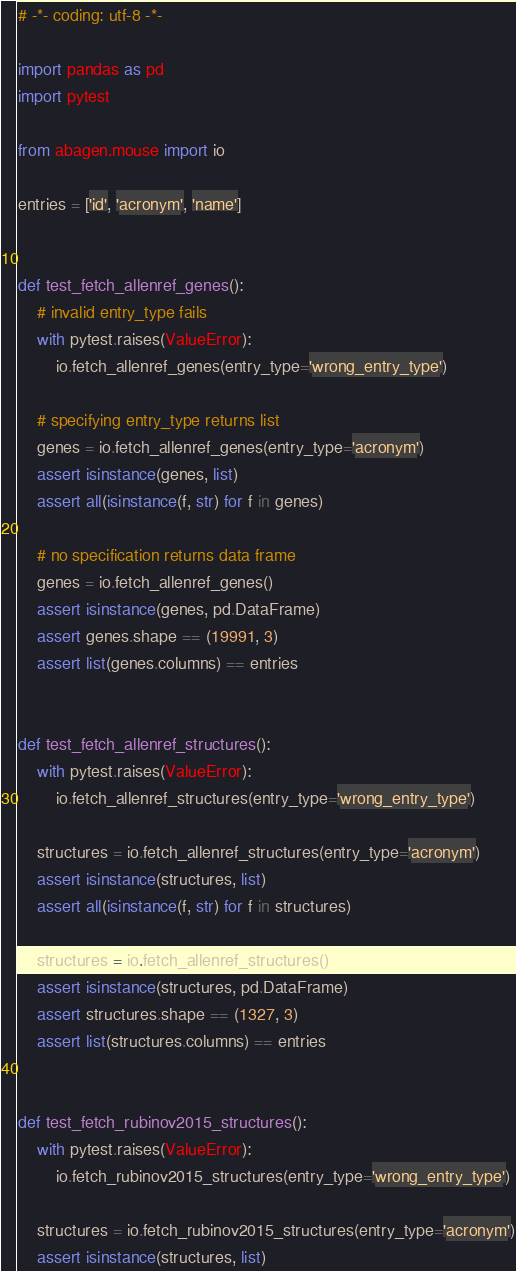<code> <loc_0><loc_0><loc_500><loc_500><_Python_># -*- coding: utf-8 -*-

import pandas as pd
import pytest

from abagen.mouse import io

entries = ['id', 'acronym', 'name']


def test_fetch_allenref_genes():
    # invalid entry_type fails
    with pytest.raises(ValueError):
        io.fetch_allenref_genes(entry_type='wrong_entry_type')

    # specifying entry_type returns list
    genes = io.fetch_allenref_genes(entry_type='acronym')
    assert isinstance(genes, list)
    assert all(isinstance(f, str) for f in genes)

    # no specification returns data frame
    genes = io.fetch_allenref_genes()
    assert isinstance(genes, pd.DataFrame)
    assert genes.shape == (19991, 3)
    assert list(genes.columns) == entries


def test_fetch_allenref_structures():
    with pytest.raises(ValueError):
        io.fetch_allenref_structures(entry_type='wrong_entry_type')

    structures = io.fetch_allenref_structures(entry_type='acronym')
    assert isinstance(structures, list)
    assert all(isinstance(f, str) for f in structures)

    structures = io.fetch_allenref_structures()
    assert isinstance(structures, pd.DataFrame)
    assert structures.shape == (1327, 3)
    assert list(structures.columns) == entries


def test_fetch_rubinov2015_structures():
    with pytest.raises(ValueError):
        io.fetch_rubinov2015_structures(entry_type='wrong_entry_type')

    structures = io.fetch_rubinov2015_structures(entry_type='acronym')
    assert isinstance(structures, list)</code> 